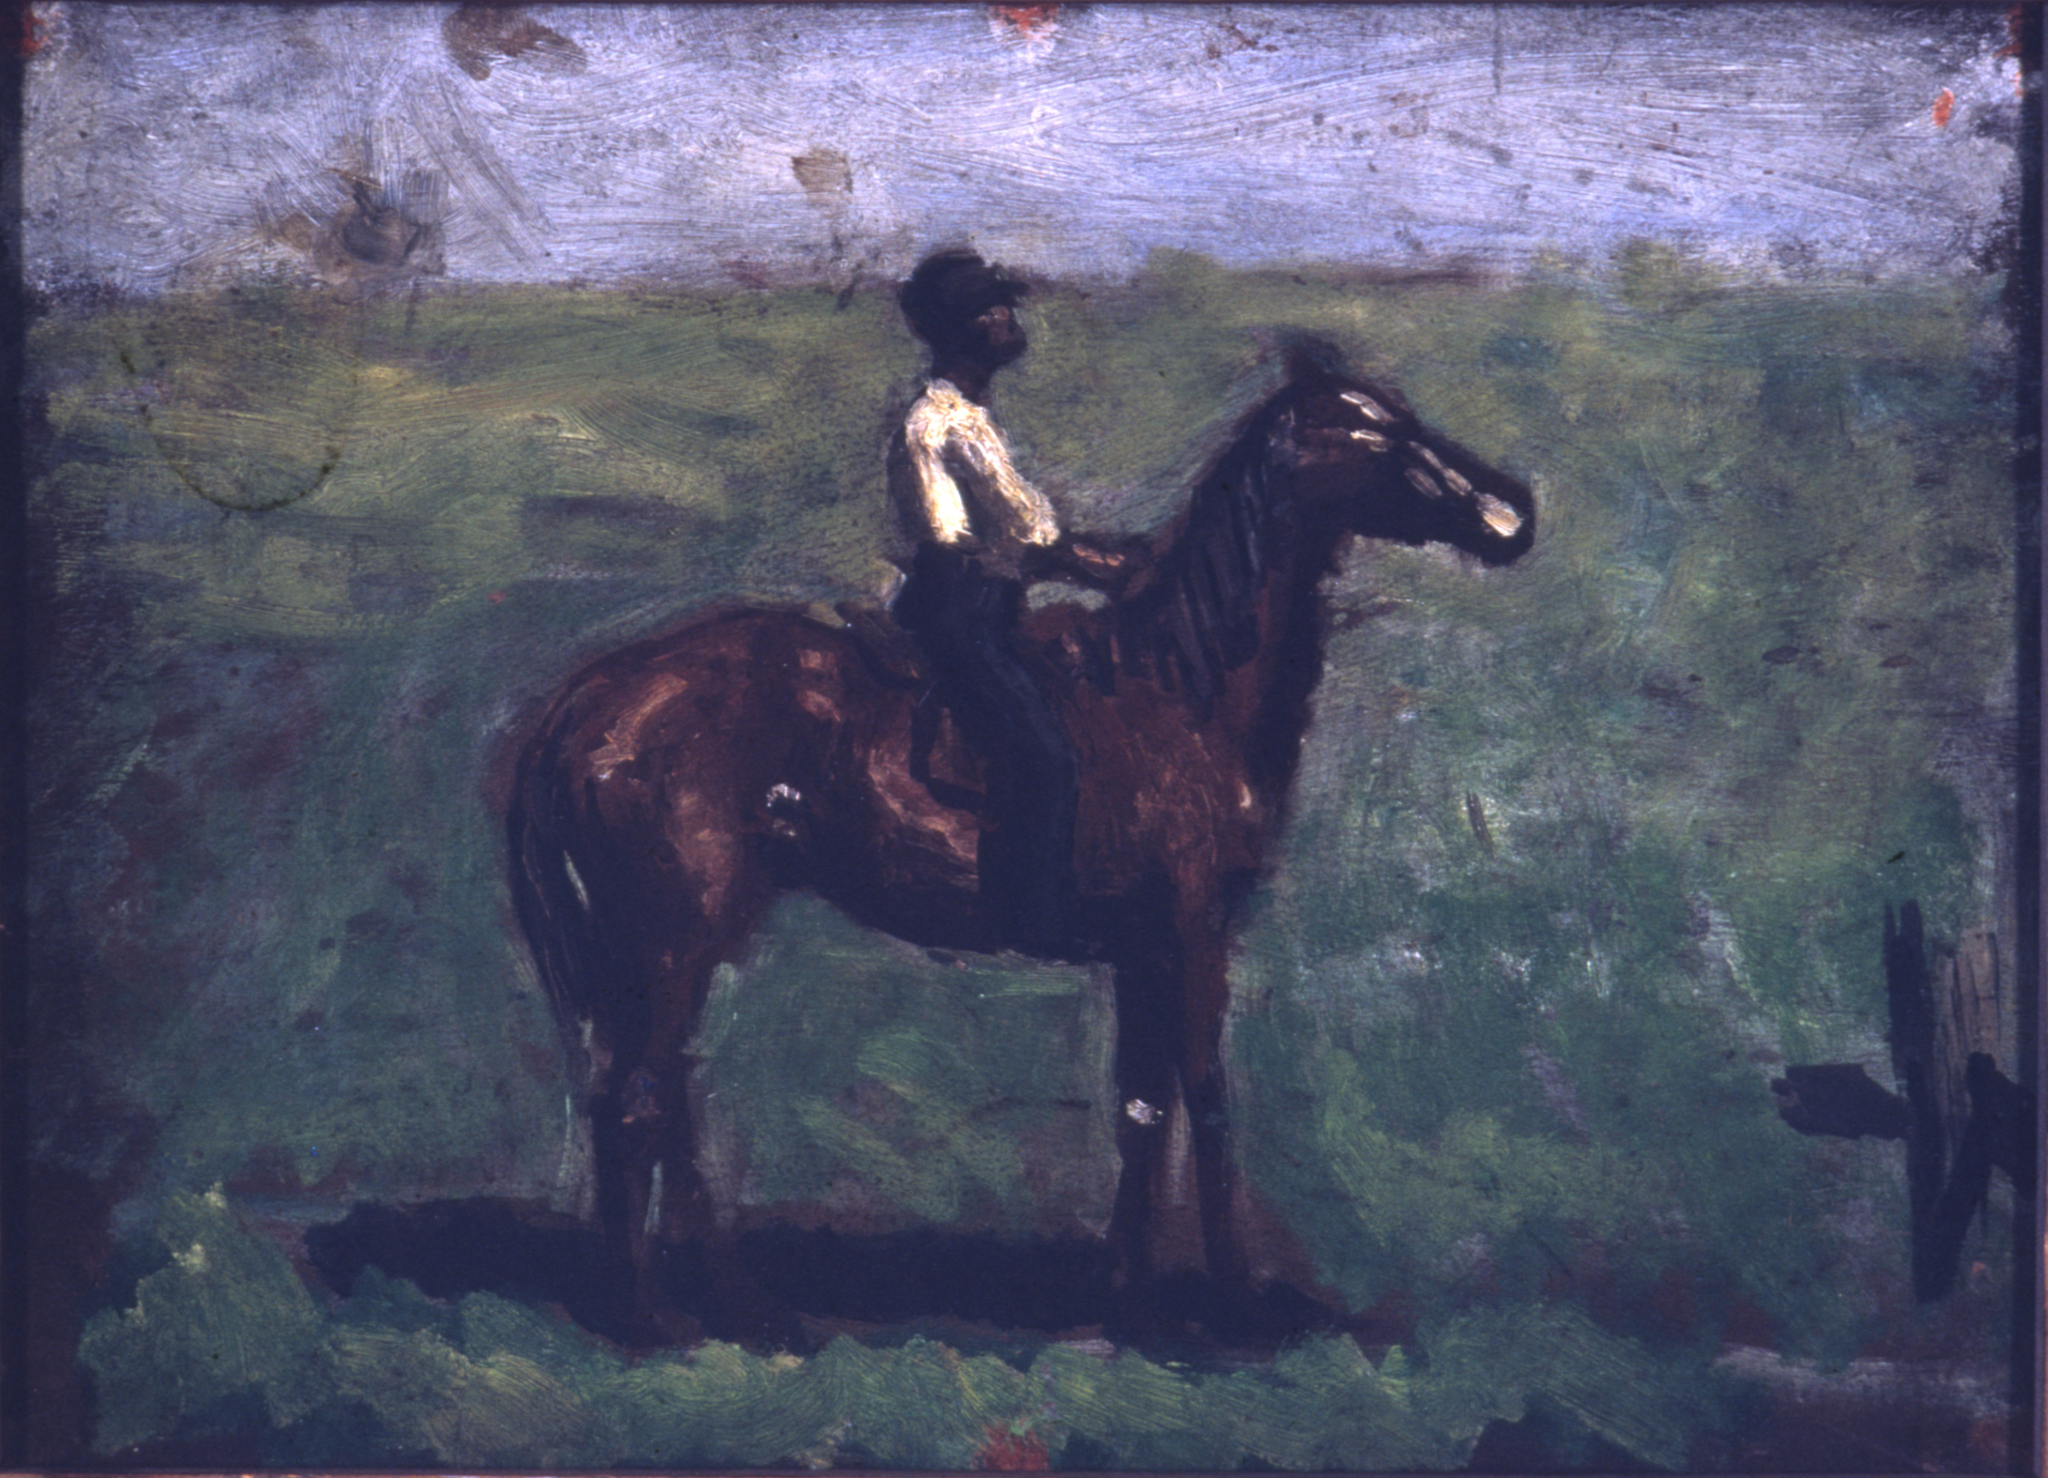What kind of daily life might the man on the horse have in his time period? The man on the horse likely leads a humble and hardworking life typical of his time. As a farmer or possibly a rural messenger, his days would be filled with manual labor from dawn until dusk. He would tend to crops, care for animals, and engage in mending and maintaining equipment. Social interactions would be few and centered around the village community, with evenings offering brief moments of solitude as he rides his horse through the countryside, seeking a connection with nature and a reprieve from his demanding routine. This painting captures one of those serene moments, reflecting the quiet and perseverance of rural life. 